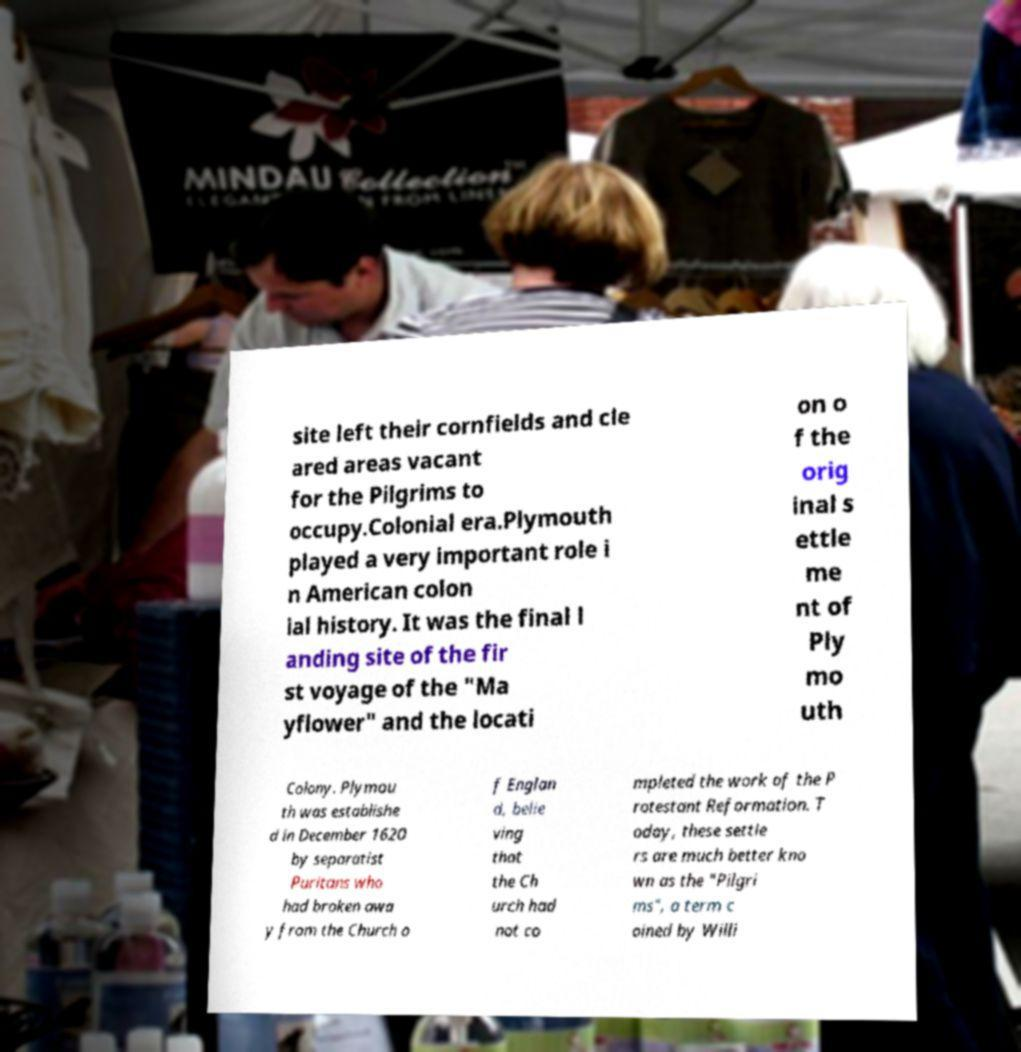Please identify and transcribe the text found in this image. site left their cornfields and cle ared areas vacant for the Pilgrims to occupy.Colonial era.Plymouth played a very important role i n American colon ial history. It was the final l anding site of the fir st voyage of the "Ma yflower" and the locati on o f the orig inal s ettle me nt of Ply mo uth Colony. Plymou th was establishe d in December 1620 by separatist Puritans who had broken awa y from the Church o f Englan d, belie ving that the Ch urch had not co mpleted the work of the P rotestant Reformation. T oday, these settle rs are much better kno wn as the "Pilgri ms", a term c oined by Willi 